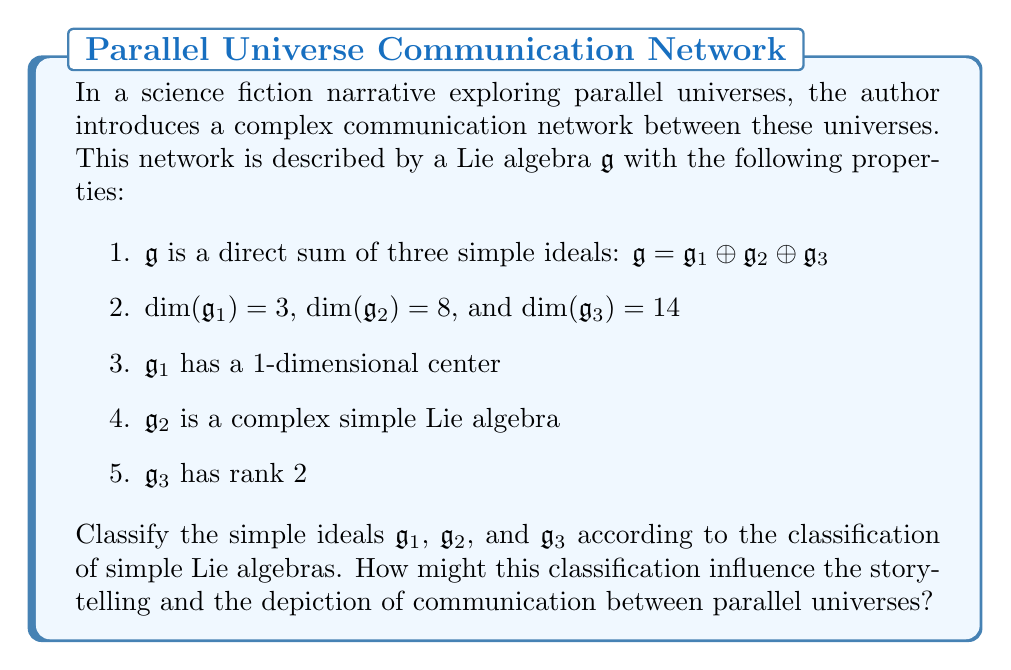Can you solve this math problem? To classify the simple ideals, we'll analyze each one based on the given information and match them to known simple Lie algebras:

1. $\mathfrak{g}_1$:
   - Dimension 3 with a 1-dimensional center
   - The only 3-dimensional Lie algebra with a 1-dimensional center is $\mathfrak{so}(3)$, which is isomorphic to $\mathfrak{su}(2)$
   - $\mathfrak{g}_1 \cong \mathfrak{su}(2)$

2. $\mathfrak{g}_2$:
   - 8-dimensional complex simple Lie algebra
   - The only 8-dimensional complex simple Lie algebra is $\mathfrak{sl}(3, \mathbb{C})$
   - $\mathfrak{g}_2 \cong \mathfrak{sl}(3, \mathbb{C})$

3. $\mathfrak{g}_3$:
   - 14-dimensional with rank 2
   - The only simple Lie algebra satisfying these conditions is $\mathfrak{g}_2$ (not to be confused with $\mathfrak{g}_2$ in this problem)
   - $\mathfrak{g}_3 \cong \mathfrak{g}_2$ (the exceptional Lie algebra)

Storytelling implications:

1. $\mathfrak{su}(2)$ is associated with rotations and spin. This could represent the ability to "rotate" or "spin" between parallel universes, suggesting a smooth transition mechanism.

2. $\mathfrak{sl}(3, \mathbb{C})$ is related to the special linear group in 3 complex dimensions. This could imply that communication between universes involves manipulating a 3-dimensional complex space, perhaps representing different aspects of reality.

3. The exceptional Lie algebra $\mathfrak{g}_2$ has unique properties not found in classical Lie algebras. This could represent exotic or unusual forms of communication between universes, adding an element of mystery or advanced technology to the story.

The combination of these algebras suggests a multi-layered communication system, where different aspects of inter-universe interaction are governed by distinct mathematical structures. This classification can provide a rich framework for the author to develop consistent and intriguing rules for how characters or information move between parallel universes, enhancing the depth and coherence of the narrative.
Answer: The classification of the simple ideals is:
$\mathfrak{g}_1 \cong \mathfrak{su}(2)$
$\mathfrak{g}_2 \cong \mathfrak{sl}(3, \mathbb{C})$
$\mathfrak{g}_3 \cong \mathfrak{g}_2$ (the exceptional Lie algebra) 